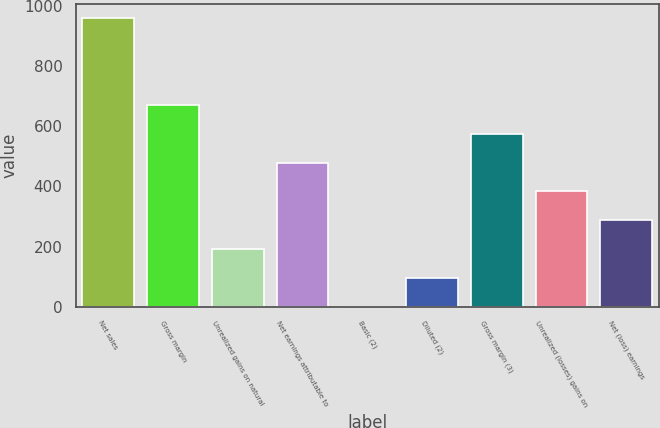Convert chart. <chart><loc_0><loc_0><loc_500><loc_500><bar_chart><fcel>Net sales<fcel>Gross margin<fcel>Unrealized gains on natural<fcel>Net earnings attributable to<fcel>Basic (2)<fcel>Diluted (2)<fcel>Gross margin (3)<fcel>Unrealized (losses) gains on<fcel>Net (loss) earnings<nl><fcel>957<fcel>669.96<fcel>191.61<fcel>478.62<fcel>0.27<fcel>95.94<fcel>574.29<fcel>382.95<fcel>287.28<nl></chart> 